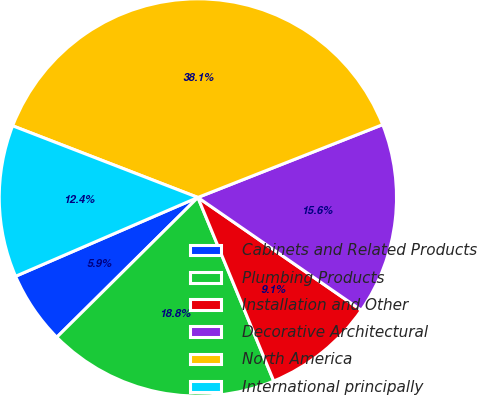Convert chart to OTSL. <chart><loc_0><loc_0><loc_500><loc_500><pie_chart><fcel>Cabinets and Related Products<fcel>Plumbing Products<fcel>Installation and Other<fcel>Decorative Architectural<fcel>North America<fcel>International principally<nl><fcel>5.93%<fcel>18.81%<fcel>9.15%<fcel>15.59%<fcel>38.15%<fcel>12.37%<nl></chart> 